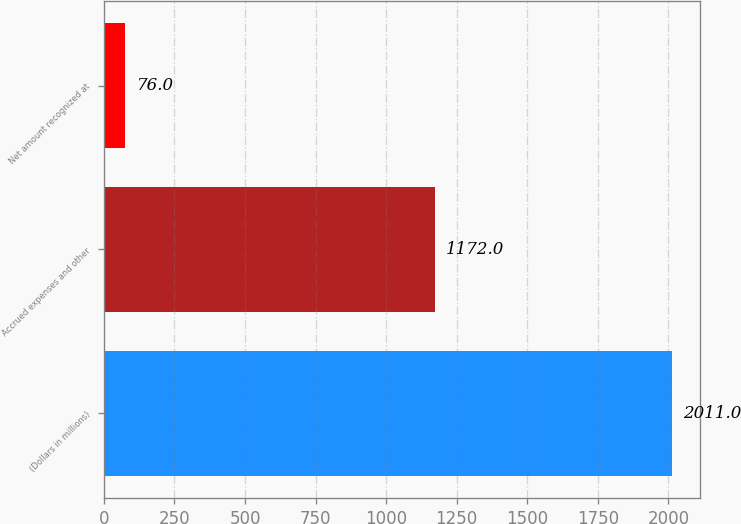Convert chart. <chart><loc_0><loc_0><loc_500><loc_500><bar_chart><fcel>(Dollars in millions)<fcel>Accrued expenses and other<fcel>Net amount recognized at<nl><fcel>2011<fcel>1172<fcel>76<nl></chart> 